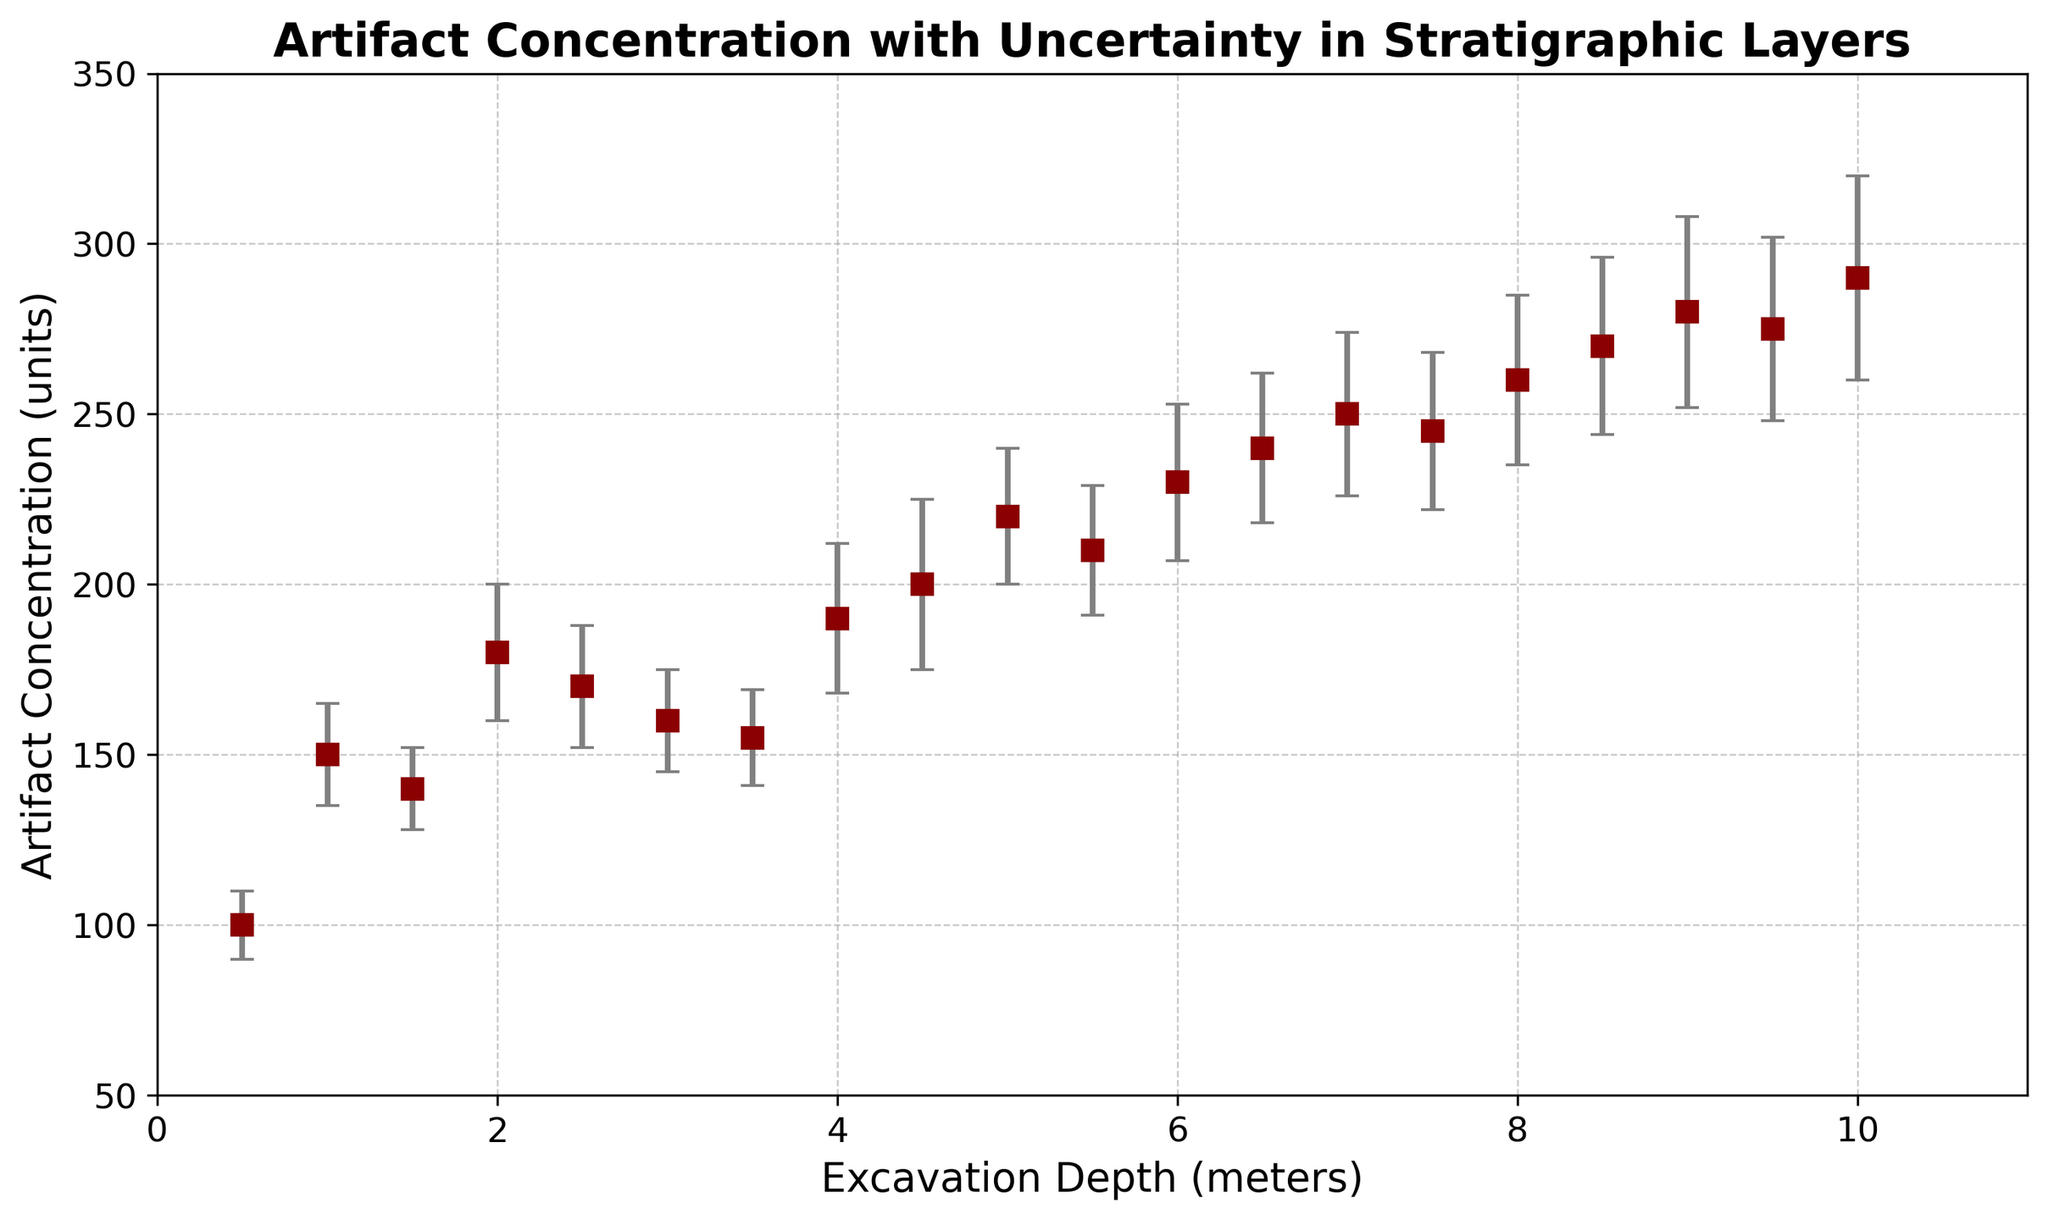Which depth has the highest artifact concentration? The depth with the highest artifact concentration is found by looking for the peak value on the y-axis (artifact concentration) of the plot. The highest point is at a concentration of 290 units, located at a depth of 10 meters.
Answer: 10 meters What is the average artifact concentration between 1.0 and 3.0 meters? We find the values of artifact concentration at depths 1.0, 1.5, 2.0, 2.5, and 3.0 meters and calculate their average. The values are 150, 140, 180, 170, and 160 units respectively. Average = (150 + 140 + 180 + 170 + 160) / 5 = 160 units.
Answer: 160 units Between 4.0 and 6.0 meters, which depth has the largest error? Looking at the error bars for each depth within the 4.0 to 6.0 meters range, the largest error is found at 6.0 meters with an error of 23 units.
Answer: 6.0 meters How does the artifact concentration at 9.5 meters compare to 10.0 meters? Compare the concentration values at these depths. At 9.5 meters, the concentration is 275 units, and at 10.0 meters, it is 290 units. The concentration at 10.0 meters is higher by 15 units.
Answer: 10.0 meters has a higher concentration What is the total artifact concentration for depths 7.0 and 7.5 meters combined? Sum the artifact concentrations at depths of 7.0 and 7.5 meters. The values are 250 and 245 units respectively. Total = 250 + 245 = 495 units.
Answer: 495 units What is the range of artifact concentrations from 0.5 to 2.0 meters? The range is the difference between the maximum and minimum artifact concentrations within the given depths. The values are 100, 150, 140, and 180 units. Range = 180 - 100 = 80 units.
Answer: 80 units Which depth shows the smallest error in artifact concentration measurement? By visually inspecting the error bars, the smallest error is at 1.5 meters with an error of 12 units.
Answer: 1.5 meters Is there any depth where the artifact concentration remains constant when considering the error margins? We review the plot to identify if any error bars overlap adjacent points, indicating constant concentration. Between depths of 7.5 and 8.0 meters, the error margins do overlap indicating similar concentrations within the error range.
Answer: 7.5 to 8.0 meters 